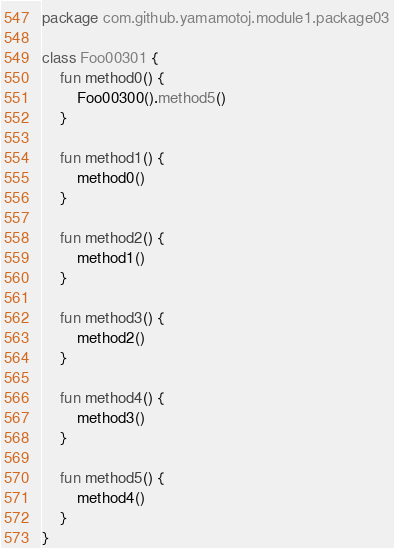Convert code to text. <code><loc_0><loc_0><loc_500><loc_500><_Kotlin_>package com.github.yamamotoj.module1.package03

class Foo00301 {
    fun method0() {
        Foo00300().method5()
    }

    fun method1() {
        method0()
    }

    fun method2() {
        method1()
    }

    fun method3() {
        method2()
    }

    fun method4() {
        method3()
    }

    fun method5() {
        method4()
    }
}
</code> 